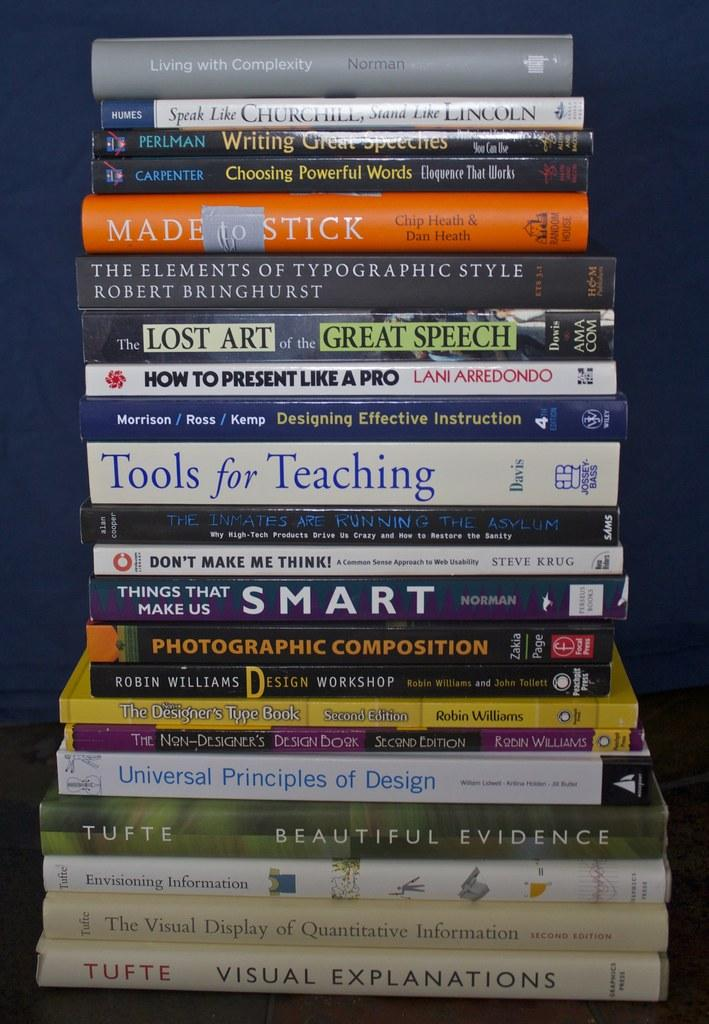<image>
Provide a brief description of the given image. A stack of books with one titled "Visual Explanation" at the bottom. 